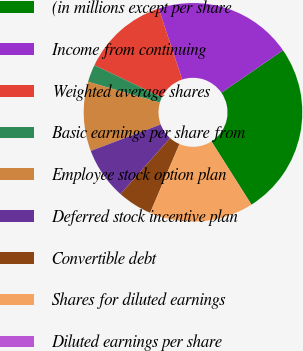<chart> <loc_0><loc_0><loc_500><loc_500><pie_chart><fcel>(in millions except per share<fcel>Income from continuing<fcel>Weighted average shares<fcel>Basic earnings per share from<fcel>Employee stock option plan<fcel>Deferred stock incentive plan<fcel>Convertible debt<fcel>Shares for diluted earnings<fcel>Diluted earnings per share<nl><fcel>25.61%<fcel>20.49%<fcel>12.82%<fcel>2.58%<fcel>10.26%<fcel>7.7%<fcel>5.14%<fcel>15.38%<fcel>0.02%<nl></chart> 